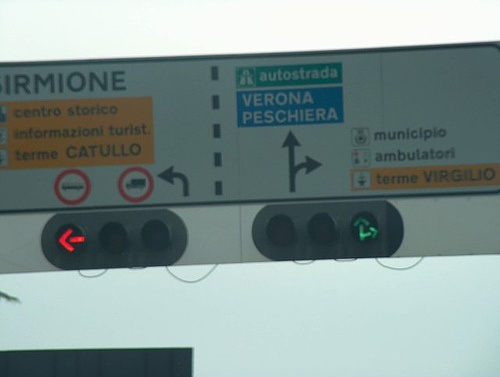Describe the objects in this image and their specific colors. I can see traffic light in ivory, black, purple, and gray tones and traffic light in ivory, black, purple, and gray tones in this image. 